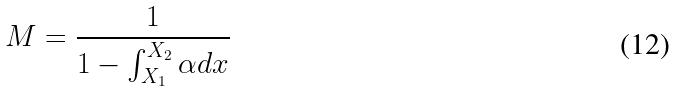<formula> <loc_0><loc_0><loc_500><loc_500>M = \frac { 1 } { 1 - \int _ { X _ { 1 } } ^ { X _ { 2 } } \alpha d x }</formula> 